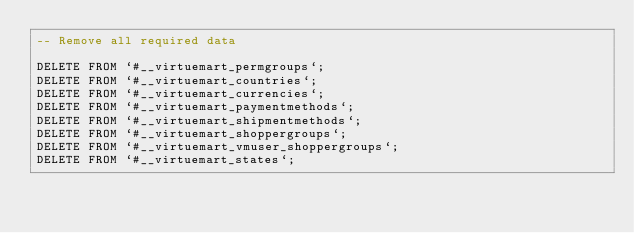Convert code to text. <code><loc_0><loc_0><loc_500><loc_500><_SQL_>-- Remove all required data

DELETE FROM `#__virtuemart_permgroups`;
DELETE FROM `#__virtuemart_countries`;
DELETE FROM `#__virtuemart_currencies`;
DELETE FROM `#__virtuemart_paymentmethods`;
DELETE FROM `#__virtuemart_shipmentmethods`;
DELETE FROM `#__virtuemart_shoppergroups`;
DELETE FROM `#__virtuemart_vmuser_shoppergroups`;
DELETE FROM `#__virtuemart_states`;</code> 